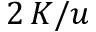Convert formula to latex. <formula><loc_0><loc_0><loc_500><loc_500>2 \, K / u</formula> 